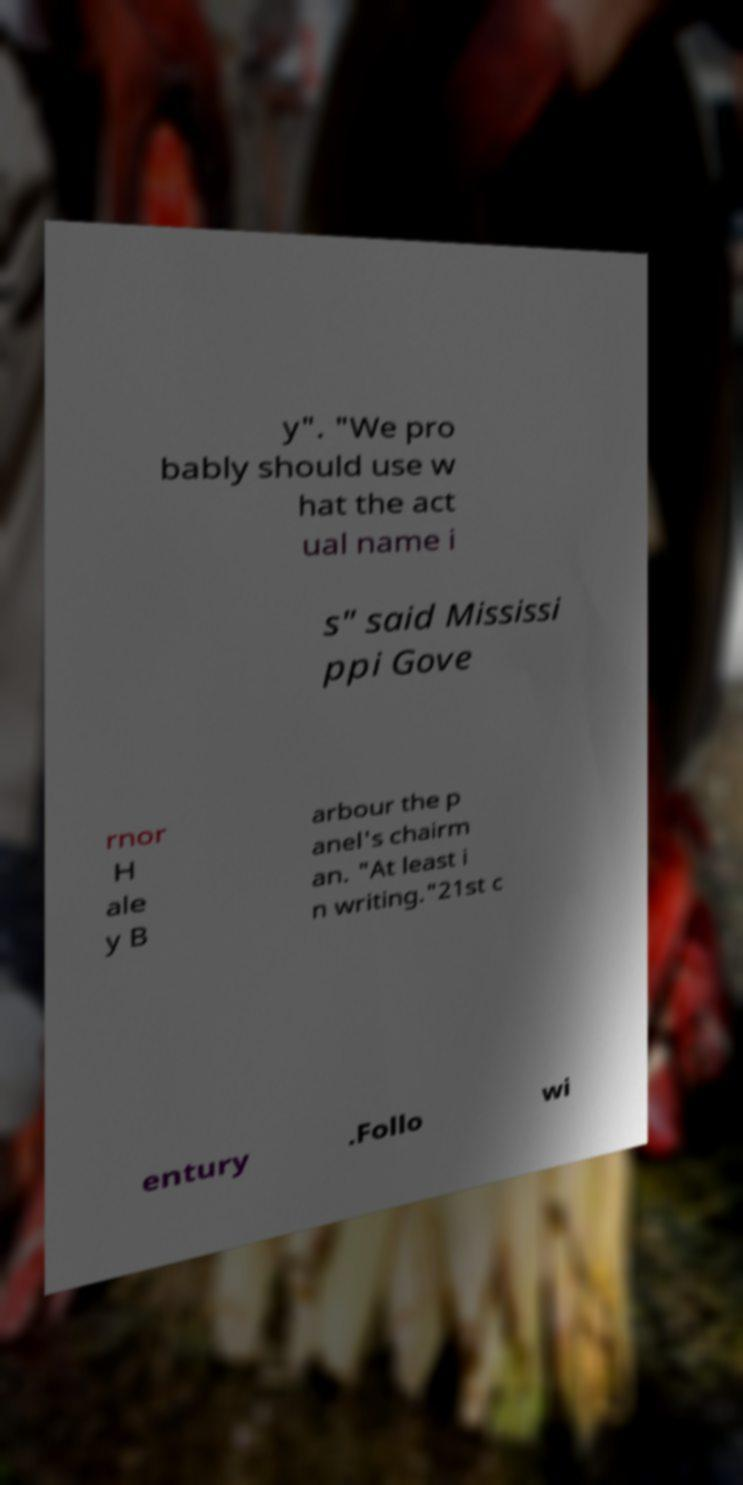Could you assist in decoding the text presented in this image and type it out clearly? y". "We pro bably should use w hat the act ual name i s" said Mississi ppi Gove rnor H ale y B arbour the p anel's chairm an. "At least i n writing."21st c entury .Follo wi 